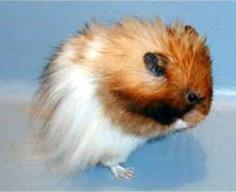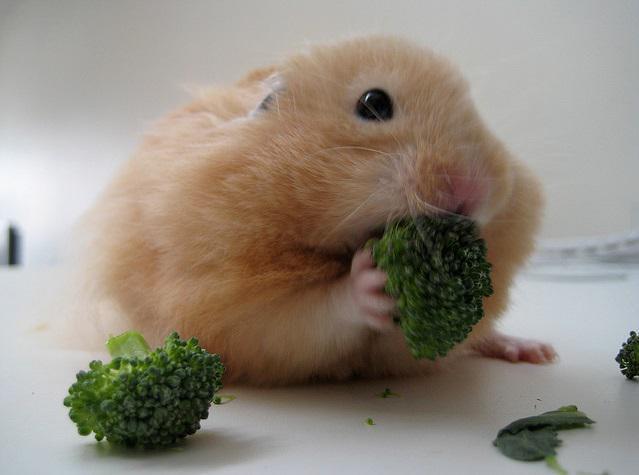The first image is the image on the left, the second image is the image on the right. For the images shown, is this caption "There is a hamster eating a piece of broccoli." true? Answer yes or no. Yes. The first image is the image on the left, the second image is the image on the right. Given the left and right images, does the statement "A light orange hamster is holding a broccoli floret to its mouth with both front paws." hold true? Answer yes or no. Yes. 